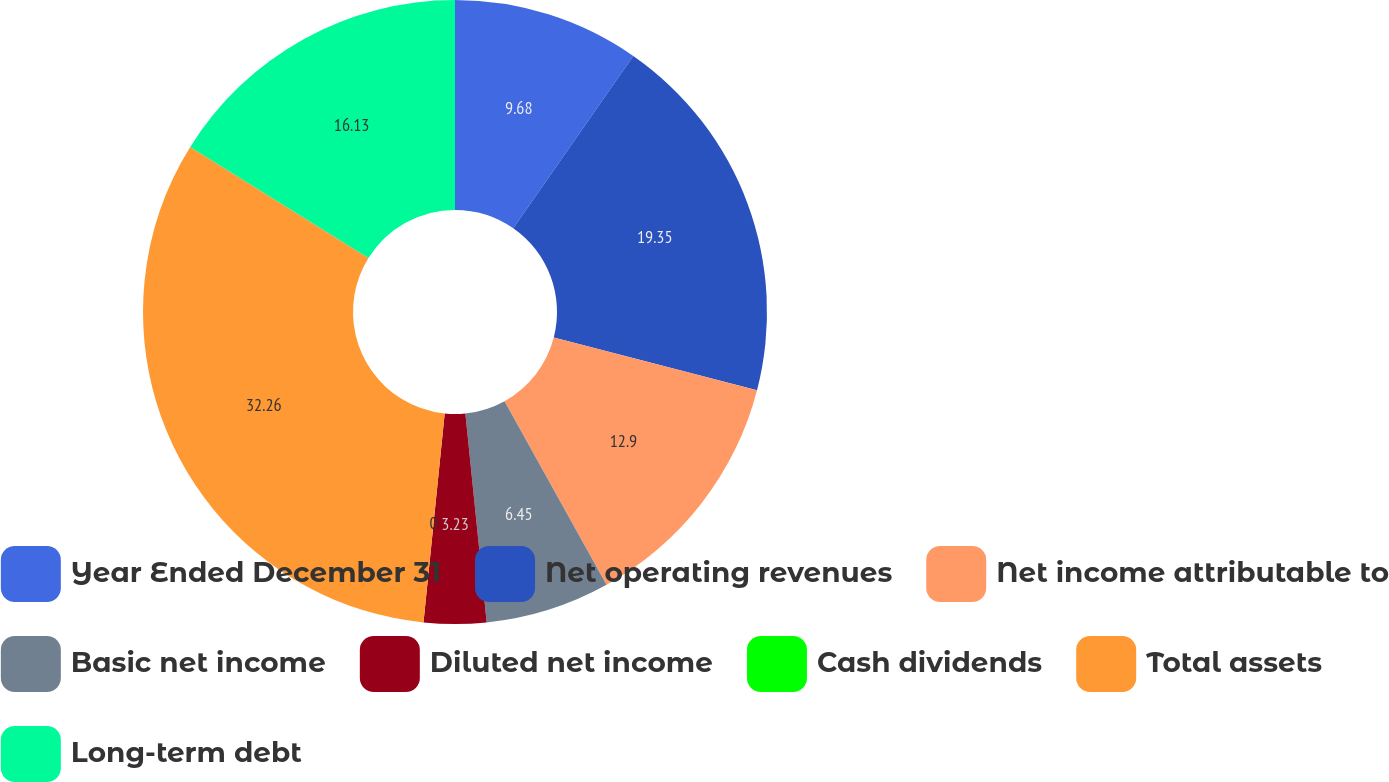<chart> <loc_0><loc_0><loc_500><loc_500><pie_chart><fcel>Year Ended December 31<fcel>Net operating revenues<fcel>Net income attributable to<fcel>Basic net income<fcel>Diluted net income<fcel>Cash dividends<fcel>Total assets<fcel>Long-term debt<nl><fcel>9.68%<fcel>19.35%<fcel>12.9%<fcel>6.45%<fcel>3.23%<fcel>0.0%<fcel>32.26%<fcel>16.13%<nl></chart> 